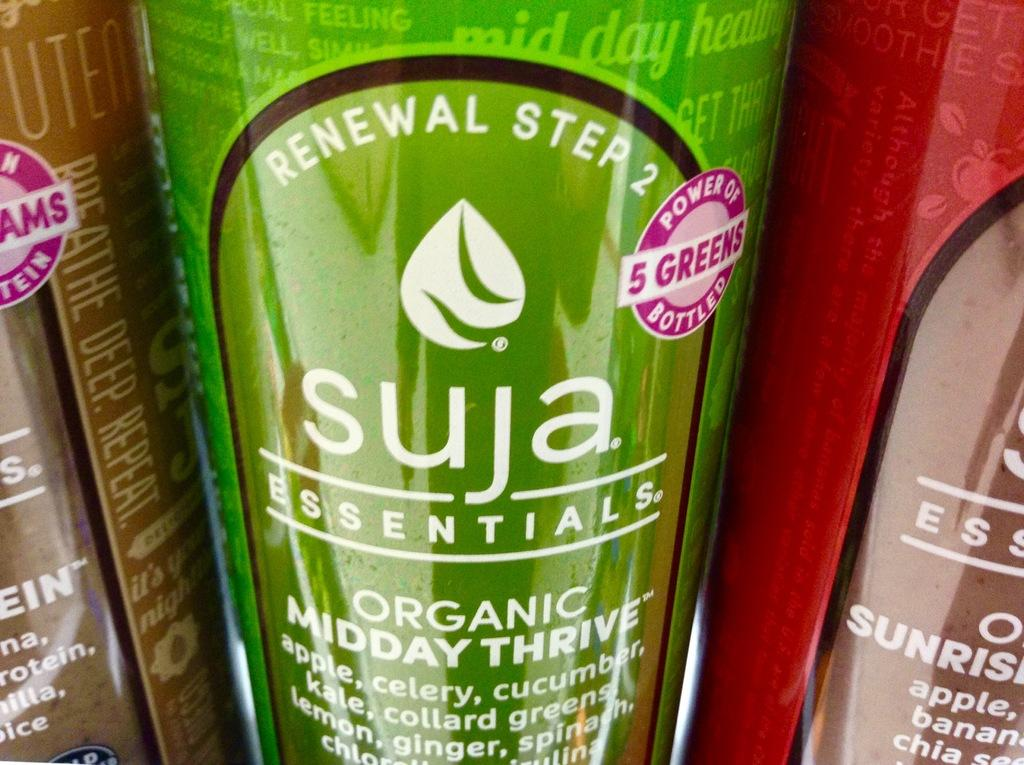<image>
Create a compact narrative representing the image presented. A green plastic bottle contains a product with the name Suja Essentials. 